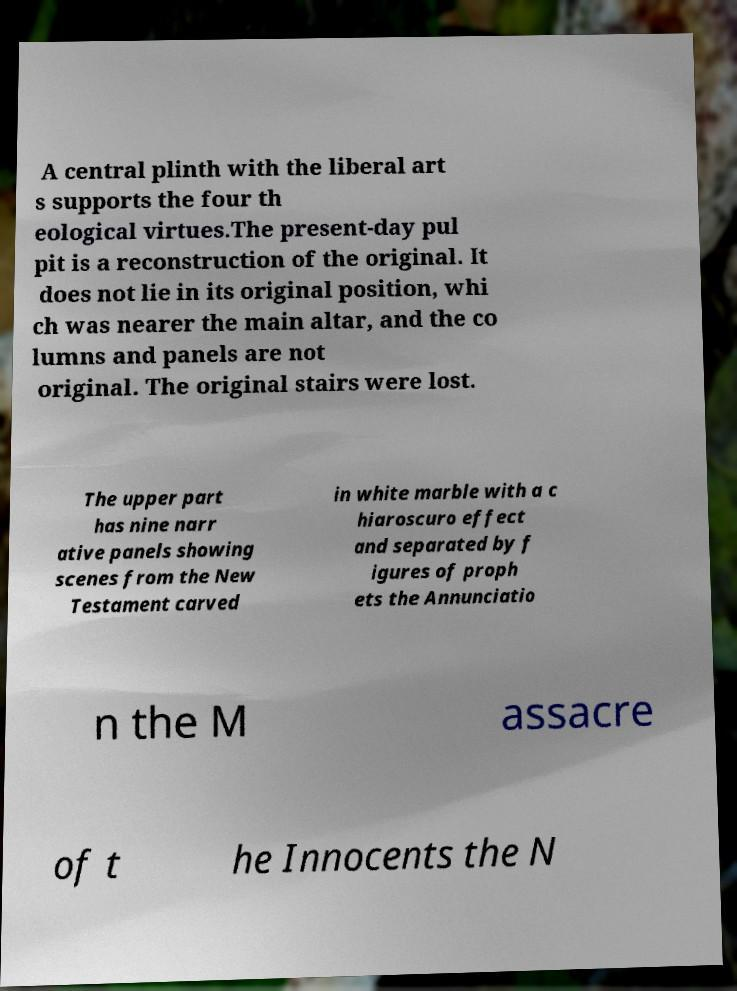I need the written content from this picture converted into text. Can you do that? A central plinth with the liberal art s supports the four th eological virtues.The present-day pul pit is a reconstruction of the original. It does not lie in its original position, whi ch was nearer the main altar, and the co lumns and panels are not original. The original stairs were lost. The upper part has nine narr ative panels showing scenes from the New Testament carved in white marble with a c hiaroscuro effect and separated by f igures of proph ets the Annunciatio n the M assacre of t he Innocents the N 